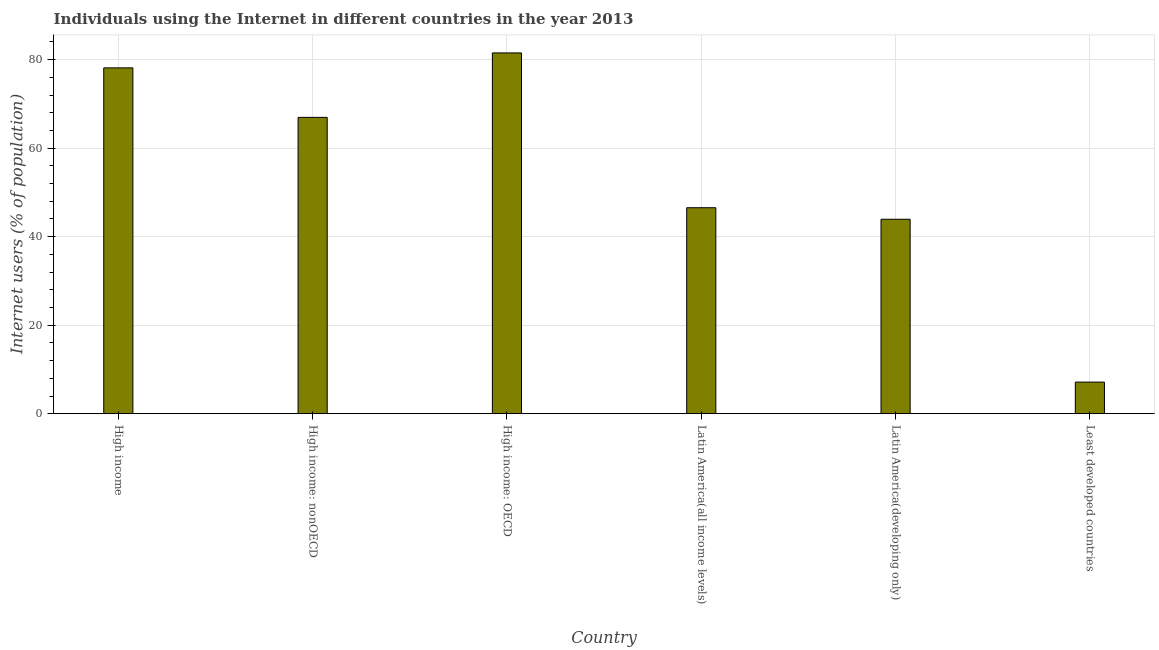Does the graph contain grids?
Your answer should be compact. Yes. What is the title of the graph?
Offer a terse response. Individuals using the Internet in different countries in the year 2013. What is the label or title of the X-axis?
Provide a succinct answer. Country. What is the label or title of the Y-axis?
Make the answer very short. Internet users (% of population). What is the number of internet users in High income?
Offer a terse response. 78.14. Across all countries, what is the maximum number of internet users?
Your answer should be very brief. 81.52. Across all countries, what is the minimum number of internet users?
Your answer should be compact. 7.15. In which country was the number of internet users maximum?
Provide a short and direct response. High income: OECD. In which country was the number of internet users minimum?
Give a very brief answer. Least developed countries. What is the sum of the number of internet users?
Your answer should be very brief. 324.25. What is the difference between the number of internet users in Latin America(all income levels) and Least developed countries?
Your response must be concise. 39.4. What is the average number of internet users per country?
Make the answer very short. 54.04. What is the median number of internet users?
Your answer should be very brief. 56.75. What is the ratio of the number of internet users in Latin America(all income levels) to that in Latin America(developing only)?
Give a very brief answer. 1.06. What is the difference between the highest and the second highest number of internet users?
Provide a short and direct response. 3.38. Is the sum of the number of internet users in Latin America(developing only) and Least developed countries greater than the maximum number of internet users across all countries?
Your answer should be very brief. No. What is the difference between the highest and the lowest number of internet users?
Keep it short and to the point. 74.37. Are all the bars in the graph horizontal?
Make the answer very short. No. What is the Internet users (% of population) in High income?
Provide a succinct answer. 78.14. What is the Internet users (% of population) in High income: nonOECD?
Your answer should be very brief. 66.96. What is the Internet users (% of population) in High income: OECD?
Provide a short and direct response. 81.52. What is the Internet users (% of population) of Latin America(all income levels)?
Offer a very short reply. 46.54. What is the Internet users (% of population) in Latin America(developing only)?
Ensure brevity in your answer.  43.94. What is the Internet users (% of population) of Least developed countries?
Offer a terse response. 7.15. What is the difference between the Internet users (% of population) in High income and High income: nonOECD?
Give a very brief answer. 11.18. What is the difference between the Internet users (% of population) in High income and High income: OECD?
Make the answer very short. -3.38. What is the difference between the Internet users (% of population) in High income and Latin America(all income levels)?
Ensure brevity in your answer.  31.6. What is the difference between the Internet users (% of population) in High income and Latin America(developing only)?
Provide a short and direct response. 34.2. What is the difference between the Internet users (% of population) in High income and Least developed countries?
Make the answer very short. 70.99. What is the difference between the Internet users (% of population) in High income: nonOECD and High income: OECD?
Make the answer very short. -14.56. What is the difference between the Internet users (% of population) in High income: nonOECD and Latin America(all income levels)?
Offer a terse response. 20.41. What is the difference between the Internet users (% of population) in High income: nonOECD and Latin America(developing only)?
Your response must be concise. 23.02. What is the difference between the Internet users (% of population) in High income: nonOECD and Least developed countries?
Your answer should be very brief. 59.81. What is the difference between the Internet users (% of population) in High income: OECD and Latin America(all income levels)?
Offer a terse response. 34.98. What is the difference between the Internet users (% of population) in High income: OECD and Latin America(developing only)?
Make the answer very short. 37.58. What is the difference between the Internet users (% of population) in High income: OECD and Least developed countries?
Ensure brevity in your answer.  74.37. What is the difference between the Internet users (% of population) in Latin America(all income levels) and Latin America(developing only)?
Offer a terse response. 2.61. What is the difference between the Internet users (% of population) in Latin America(all income levels) and Least developed countries?
Provide a short and direct response. 39.4. What is the difference between the Internet users (% of population) in Latin America(developing only) and Least developed countries?
Your answer should be very brief. 36.79. What is the ratio of the Internet users (% of population) in High income to that in High income: nonOECD?
Your response must be concise. 1.17. What is the ratio of the Internet users (% of population) in High income to that in High income: OECD?
Ensure brevity in your answer.  0.96. What is the ratio of the Internet users (% of population) in High income to that in Latin America(all income levels)?
Ensure brevity in your answer.  1.68. What is the ratio of the Internet users (% of population) in High income to that in Latin America(developing only)?
Provide a short and direct response. 1.78. What is the ratio of the Internet users (% of population) in High income to that in Least developed countries?
Ensure brevity in your answer.  10.94. What is the ratio of the Internet users (% of population) in High income: nonOECD to that in High income: OECD?
Your answer should be compact. 0.82. What is the ratio of the Internet users (% of population) in High income: nonOECD to that in Latin America(all income levels)?
Provide a short and direct response. 1.44. What is the ratio of the Internet users (% of population) in High income: nonOECD to that in Latin America(developing only)?
Provide a short and direct response. 1.52. What is the ratio of the Internet users (% of population) in High income: nonOECD to that in Least developed countries?
Make the answer very short. 9.37. What is the ratio of the Internet users (% of population) in High income: OECD to that in Latin America(all income levels)?
Give a very brief answer. 1.75. What is the ratio of the Internet users (% of population) in High income: OECD to that in Latin America(developing only)?
Your response must be concise. 1.85. What is the ratio of the Internet users (% of population) in High income: OECD to that in Least developed countries?
Your response must be concise. 11.41. What is the ratio of the Internet users (% of population) in Latin America(all income levels) to that in Latin America(developing only)?
Offer a terse response. 1.06. What is the ratio of the Internet users (% of population) in Latin America(all income levels) to that in Least developed countries?
Provide a short and direct response. 6.51. What is the ratio of the Internet users (% of population) in Latin America(developing only) to that in Least developed countries?
Make the answer very short. 6.15. 